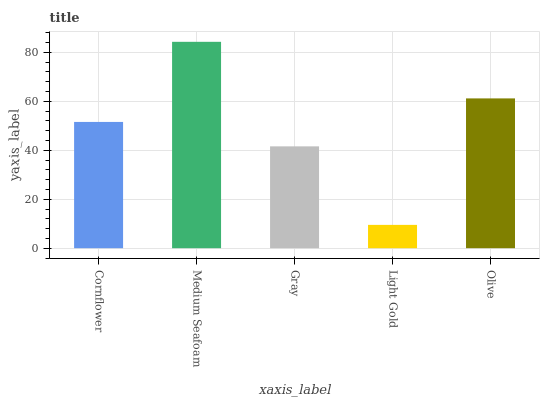Is Light Gold the minimum?
Answer yes or no. Yes. Is Medium Seafoam the maximum?
Answer yes or no. Yes. Is Gray the minimum?
Answer yes or no. No. Is Gray the maximum?
Answer yes or no. No. Is Medium Seafoam greater than Gray?
Answer yes or no. Yes. Is Gray less than Medium Seafoam?
Answer yes or no. Yes. Is Gray greater than Medium Seafoam?
Answer yes or no. No. Is Medium Seafoam less than Gray?
Answer yes or no. No. Is Cornflower the high median?
Answer yes or no. Yes. Is Cornflower the low median?
Answer yes or no. Yes. Is Light Gold the high median?
Answer yes or no. No. Is Medium Seafoam the low median?
Answer yes or no. No. 